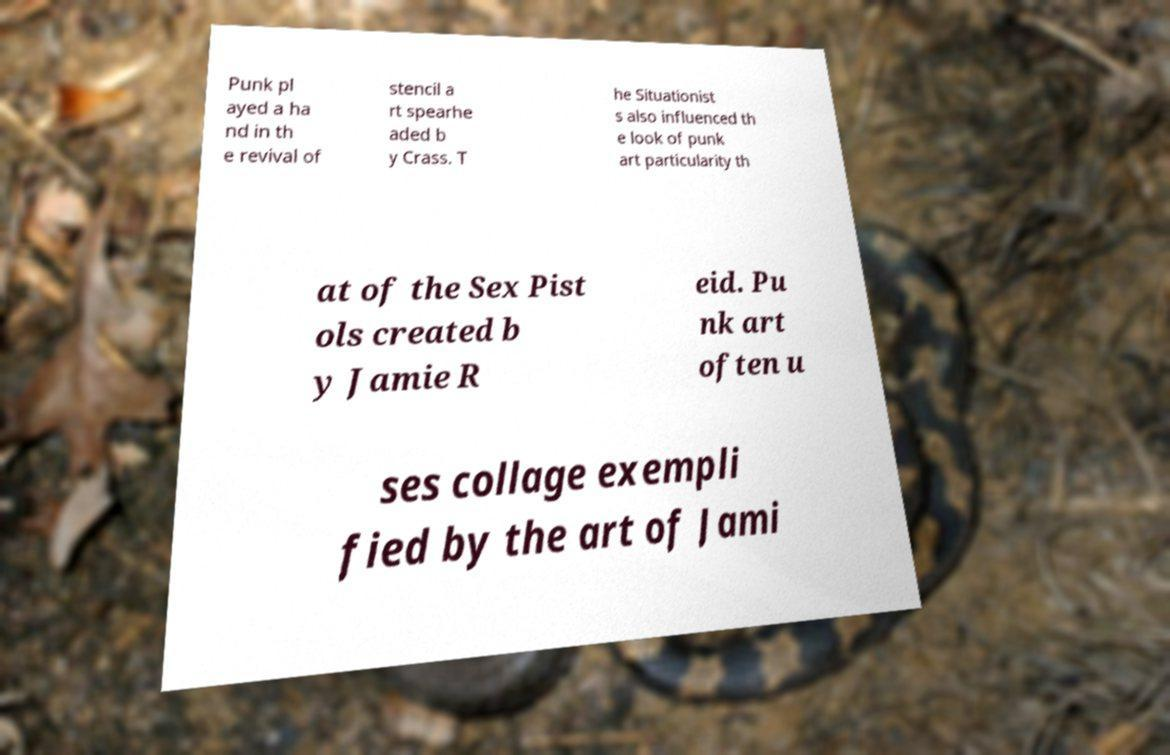I need the written content from this picture converted into text. Can you do that? Punk pl ayed a ha nd in th e revival of stencil a rt spearhe aded b y Crass. T he Situationist s also influenced th e look of punk art particularity th at of the Sex Pist ols created b y Jamie R eid. Pu nk art often u ses collage exempli fied by the art of Jami 